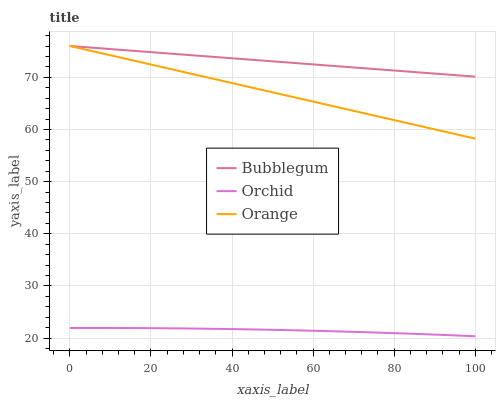Does Orchid have the minimum area under the curve?
Answer yes or no. Yes. Does Bubblegum have the maximum area under the curve?
Answer yes or no. Yes. Does Bubblegum have the minimum area under the curve?
Answer yes or no. No. Does Orchid have the maximum area under the curve?
Answer yes or no. No. Is Orange the smoothest?
Answer yes or no. Yes. Is Orchid the roughest?
Answer yes or no. Yes. Is Bubblegum the smoothest?
Answer yes or no. No. Is Bubblegum the roughest?
Answer yes or no. No. Does Orchid have the lowest value?
Answer yes or no. Yes. Does Bubblegum have the lowest value?
Answer yes or no. No. Does Bubblegum have the highest value?
Answer yes or no. Yes. Does Orchid have the highest value?
Answer yes or no. No. Is Orchid less than Bubblegum?
Answer yes or no. Yes. Is Bubblegum greater than Orchid?
Answer yes or no. Yes. Does Orange intersect Bubblegum?
Answer yes or no. Yes. Is Orange less than Bubblegum?
Answer yes or no. No. Is Orange greater than Bubblegum?
Answer yes or no. No. Does Orchid intersect Bubblegum?
Answer yes or no. No. 